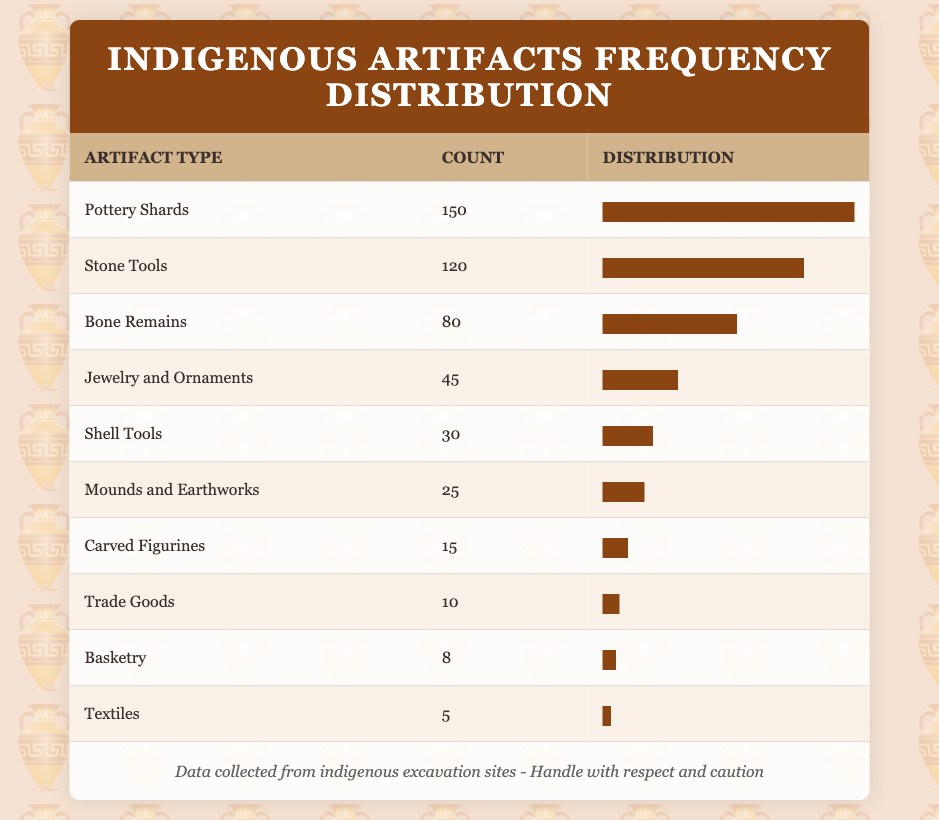What is the most commonly found artifact type? The table indicates that "Pottery Shards" have the highest count at 150, more than any other artifact type listed.
Answer: Pottery Shards How many more "Stone Tools" were found compared to "Textiles"? The count of "Stone Tools" is 120, and for "Textiles," it is 5. To find the difference, subtract 5 from 120, resulting in 115.
Answer: 115 True or False: The count of "Carved Figurines" is greater than that of "Jewelry and Ornaments." "Carved Figurines" has a count of 15 and "Jewelry and Ornaments" has a count of 45. Since 15 is less than 45, the statement is false.
Answer: False What is the total count of all the artifacts listed in the table? To find the total, we add up all the counts: 150 + 120 + 80 + 45 + 30 + 25 + 15 + 10 + 8 + 5 = 493.
Answer: 493 Which artifact type has the least frequency, and what is its count? The least number of artifacts is "Textiles," which has a count of 5. This can be observed by comparing all the counts in the table.
Answer: Textiles, 5 What is the average count of artifacts across all the types listed in the table? First, sum all the counts, which is 493. There are 10 artifact types, so divide 493 by 10 to get an average of 49.3.
Answer: 49.3 How many artifact types have a count greater than 50? By examining the table, "Pottery Shards" (150), "Stone Tools" (120), and "Bone Remains" (80) are the only types over 50, totaling three types.
Answer: 3 Is the combined count of "Trade Goods" and "Basketry" greater than the count of "Shell Tools"? "Trade Goods" has a count of 10 and "Basketry" has 8, making their combined total 18. "Shell Tools" has a count of 30, and since 18 is less than 30, the answer is no.
Answer: No 